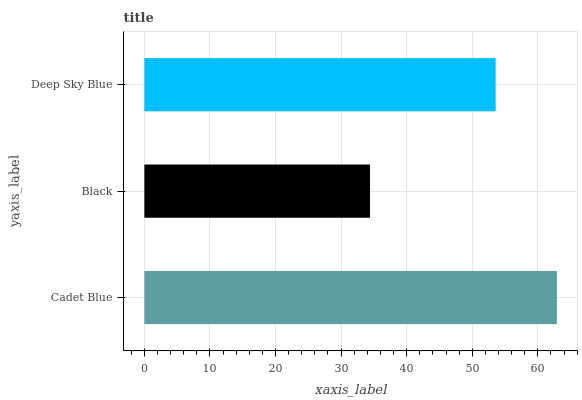Is Black the minimum?
Answer yes or no. Yes. Is Cadet Blue the maximum?
Answer yes or no. Yes. Is Deep Sky Blue the minimum?
Answer yes or no. No. Is Deep Sky Blue the maximum?
Answer yes or no. No. Is Deep Sky Blue greater than Black?
Answer yes or no. Yes. Is Black less than Deep Sky Blue?
Answer yes or no. Yes. Is Black greater than Deep Sky Blue?
Answer yes or no. No. Is Deep Sky Blue less than Black?
Answer yes or no. No. Is Deep Sky Blue the high median?
Answer yes or no. Yes. Is Deep Sky Blue the low median?
Answer yes or no. Yes. Is Cadet Blue the high median?
Answer yes or no. No. Is Black the low median?
Answer yes or no. No. 